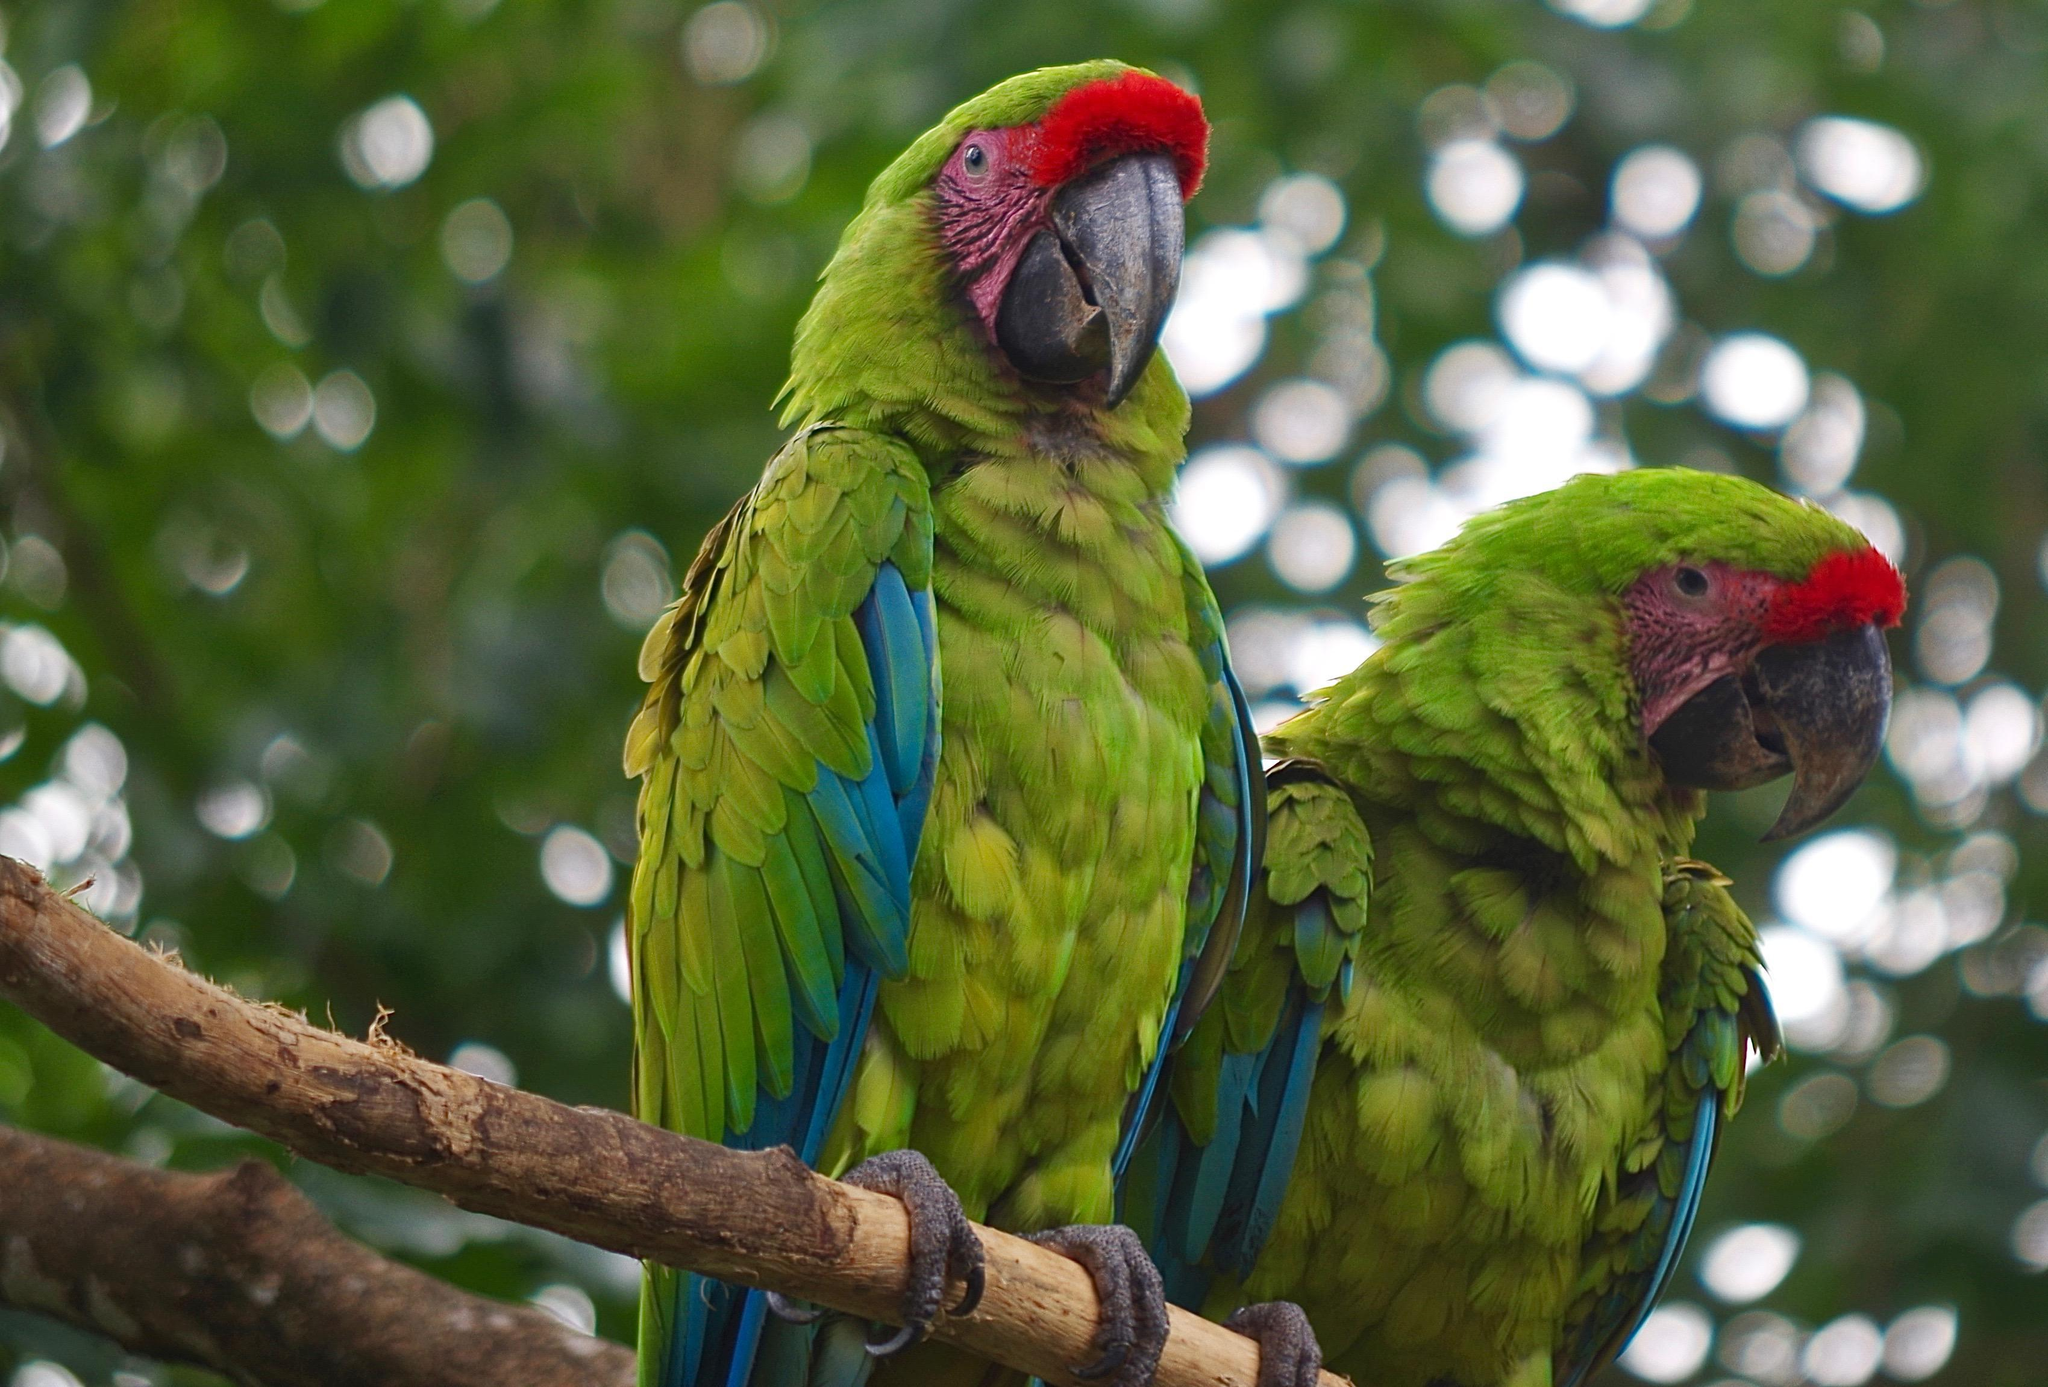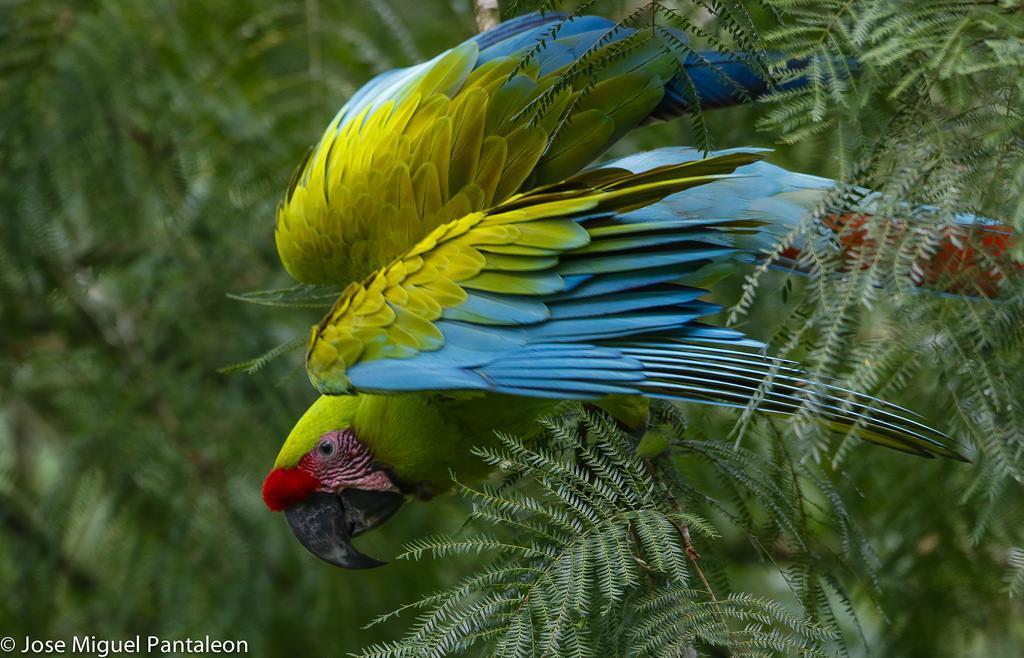The first image is the image on the left, the second image is the image on the right. Assess this claim about the two images: "All birds are perched with wings folded, and at least one image shows multiple birds with the same coloring.". Correct or not? Answer yes or no. No. 